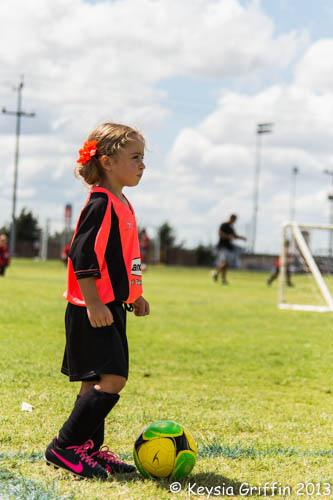What kind of poles stand erect in the background?

Choices:
A) telephone
B) wind
C) electric
D) solar electric 